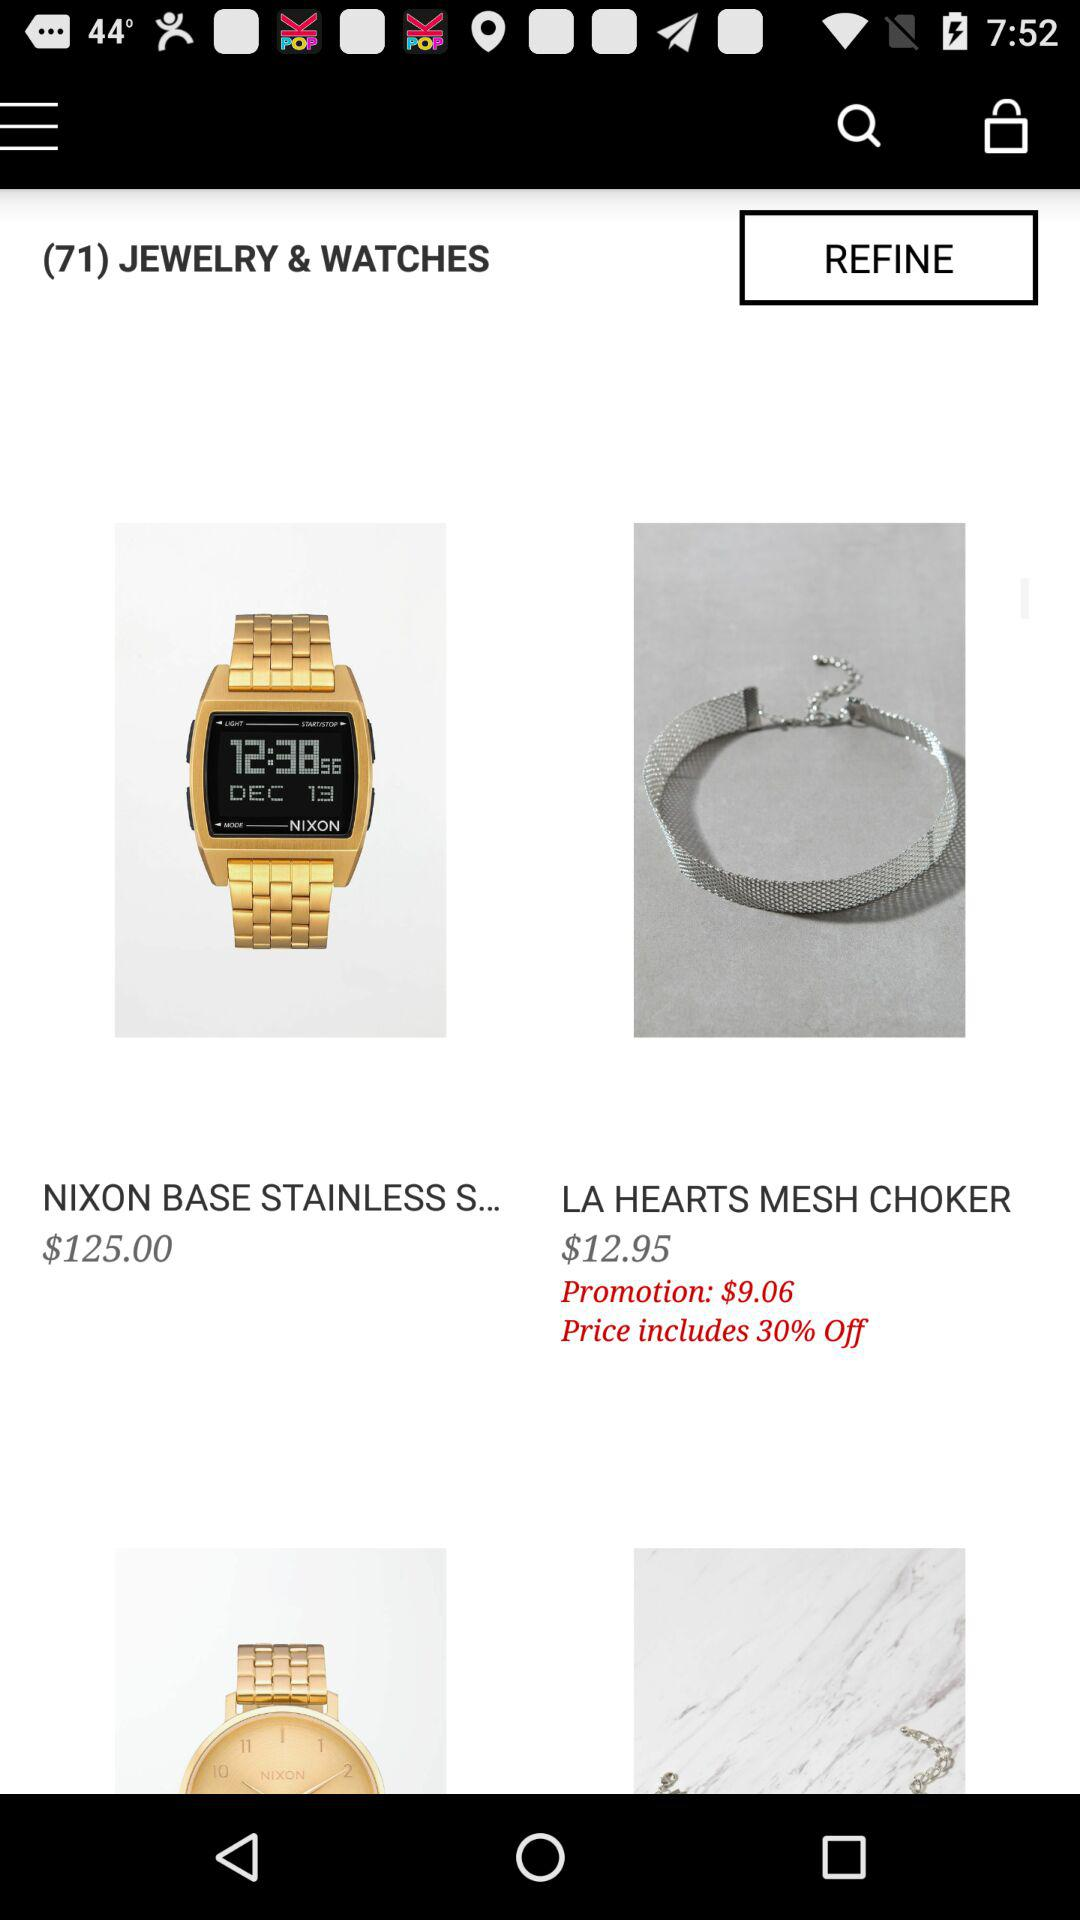How many items are in the jewelry and watches category?
Answer the question using a single word or phrase. 71 